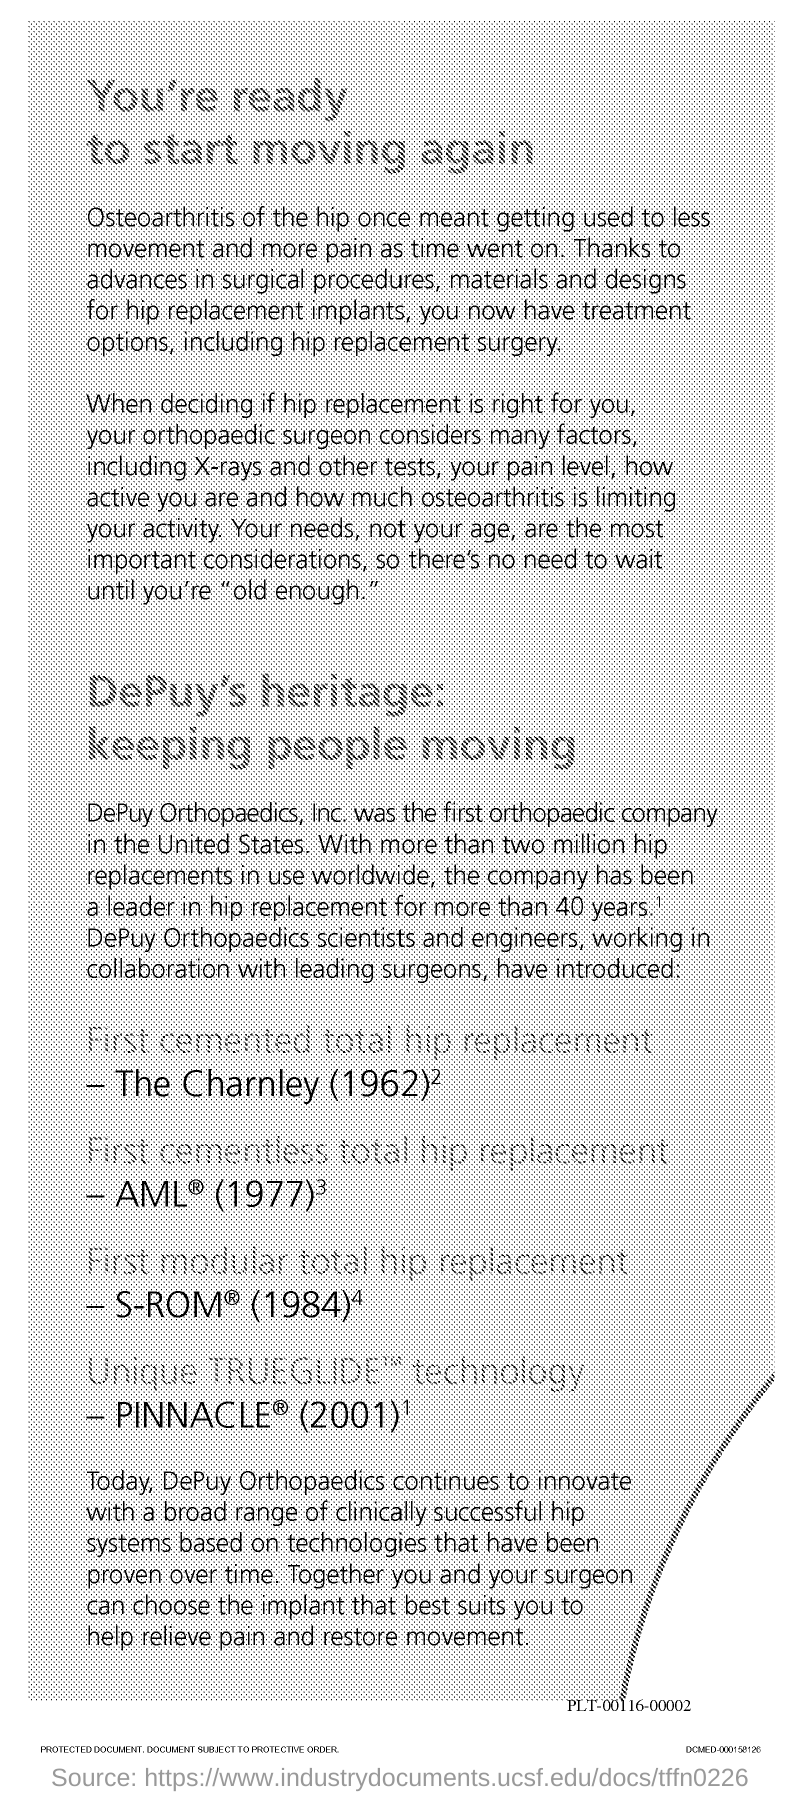Highlight a few significant elements in this photo. DePuy Orthopaedics, Inc. was the first orthopaedic company in the United States. 